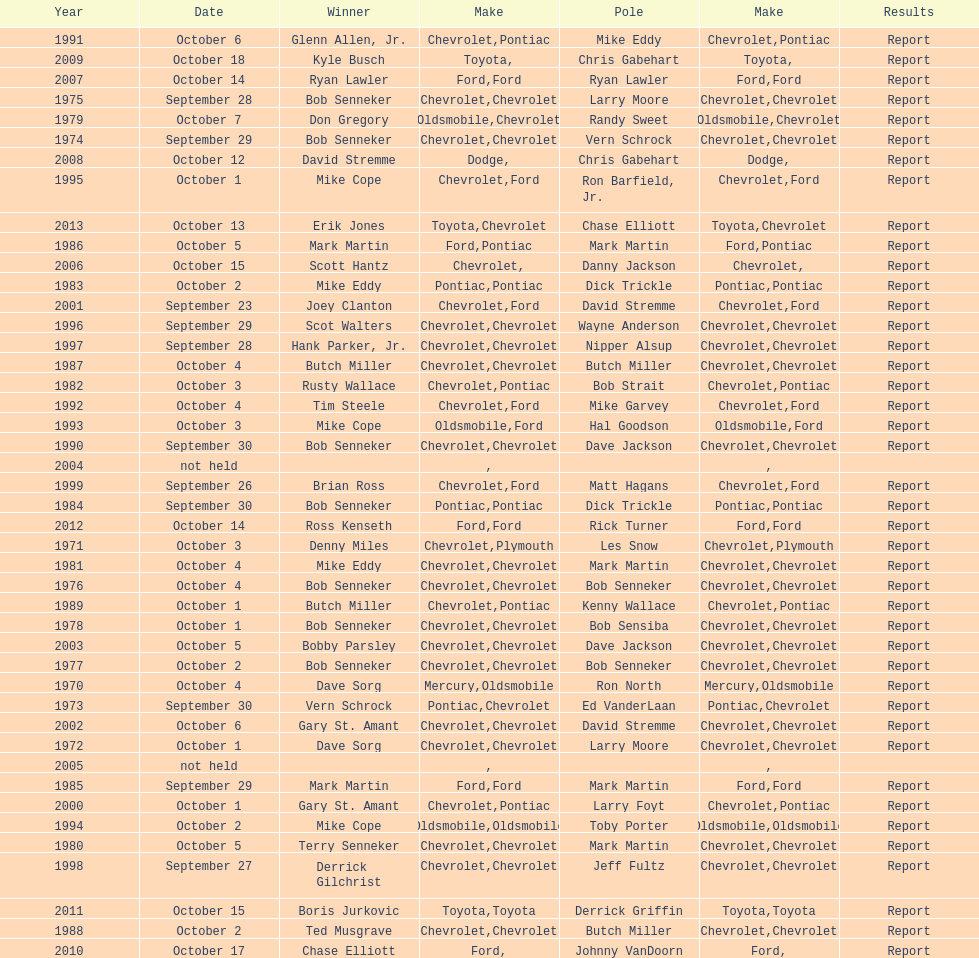Which month held the most winchester 400 races? October. 